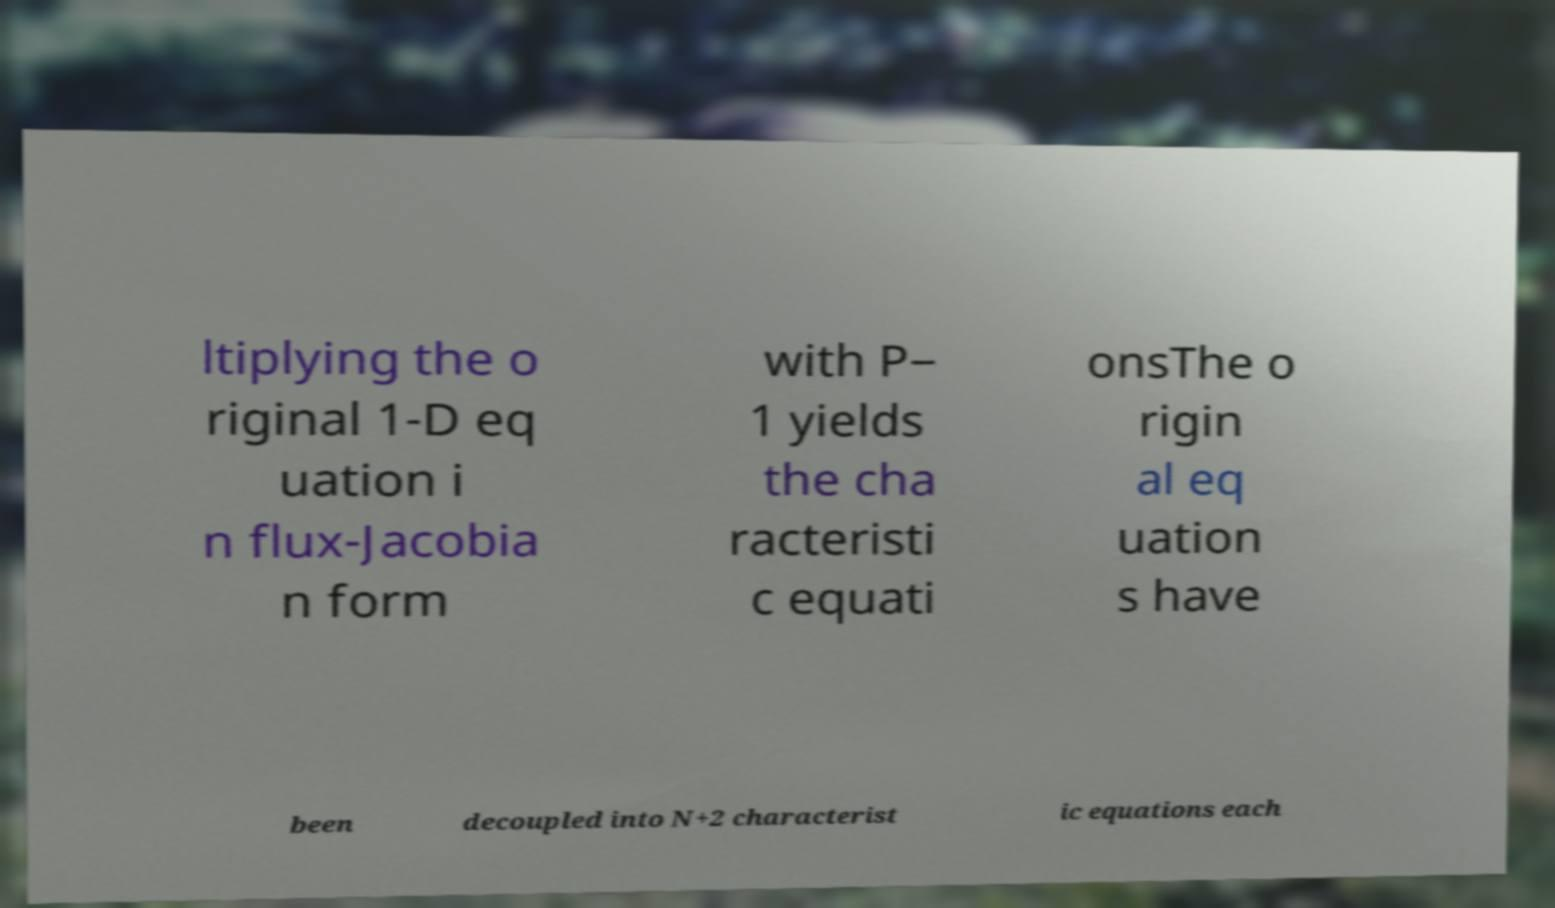Can you accurately transcribe the text from the provided image for me? ltiplying the o riginal 1-D eq uation i n flux-Jacobia n form with P− 1 yields the cha racteristi c equati onsThe o rigin al eq uation s have been decoupled into N+2 characterist ic equations each 